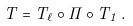<formula> <loc_0><loc_0><loc_500><loc_500>T = T _ { \ell } \circ \cdots \circ T _ { 1 } \, .</formula> 